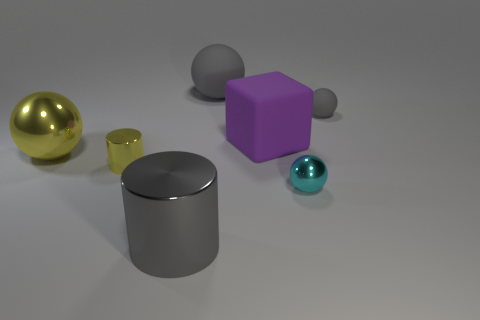There is another ball that is the same color as the large rubber ball; what is its material?
Your answer should be compact. Rubber. How many balls are to the left of the gray rubber object to the left of the gray matte ball that is to the right of the cyan metallic sphere?
Give a very brief answer. 1. What number of gray objects are large balls or metallic things?
Offer a very short reply. 2. The big cube that is made of the same material as the tiny gray thing is what color?
Your answer should be compact. Purple. Are there any other things that have the same size as the cyan ball?
Offer a terse response. Yes. What number of tiny objects are either gray shiny spheres or metal spheres?
Give a very brief answer. 1. Is the number of yellow metal cylinders less than the number of gray spheres?
Provide a succinct answer. Yes. The big rubber thing that is the same shape as the big yellow metal object is what color?
Your answer should be compact. Gray. Is there any other thing that has the same shape as the purple matte object?
Provide a succinct answer. No. Are there more big purple things than small red cubes?
Offer a terse response. Yes. 